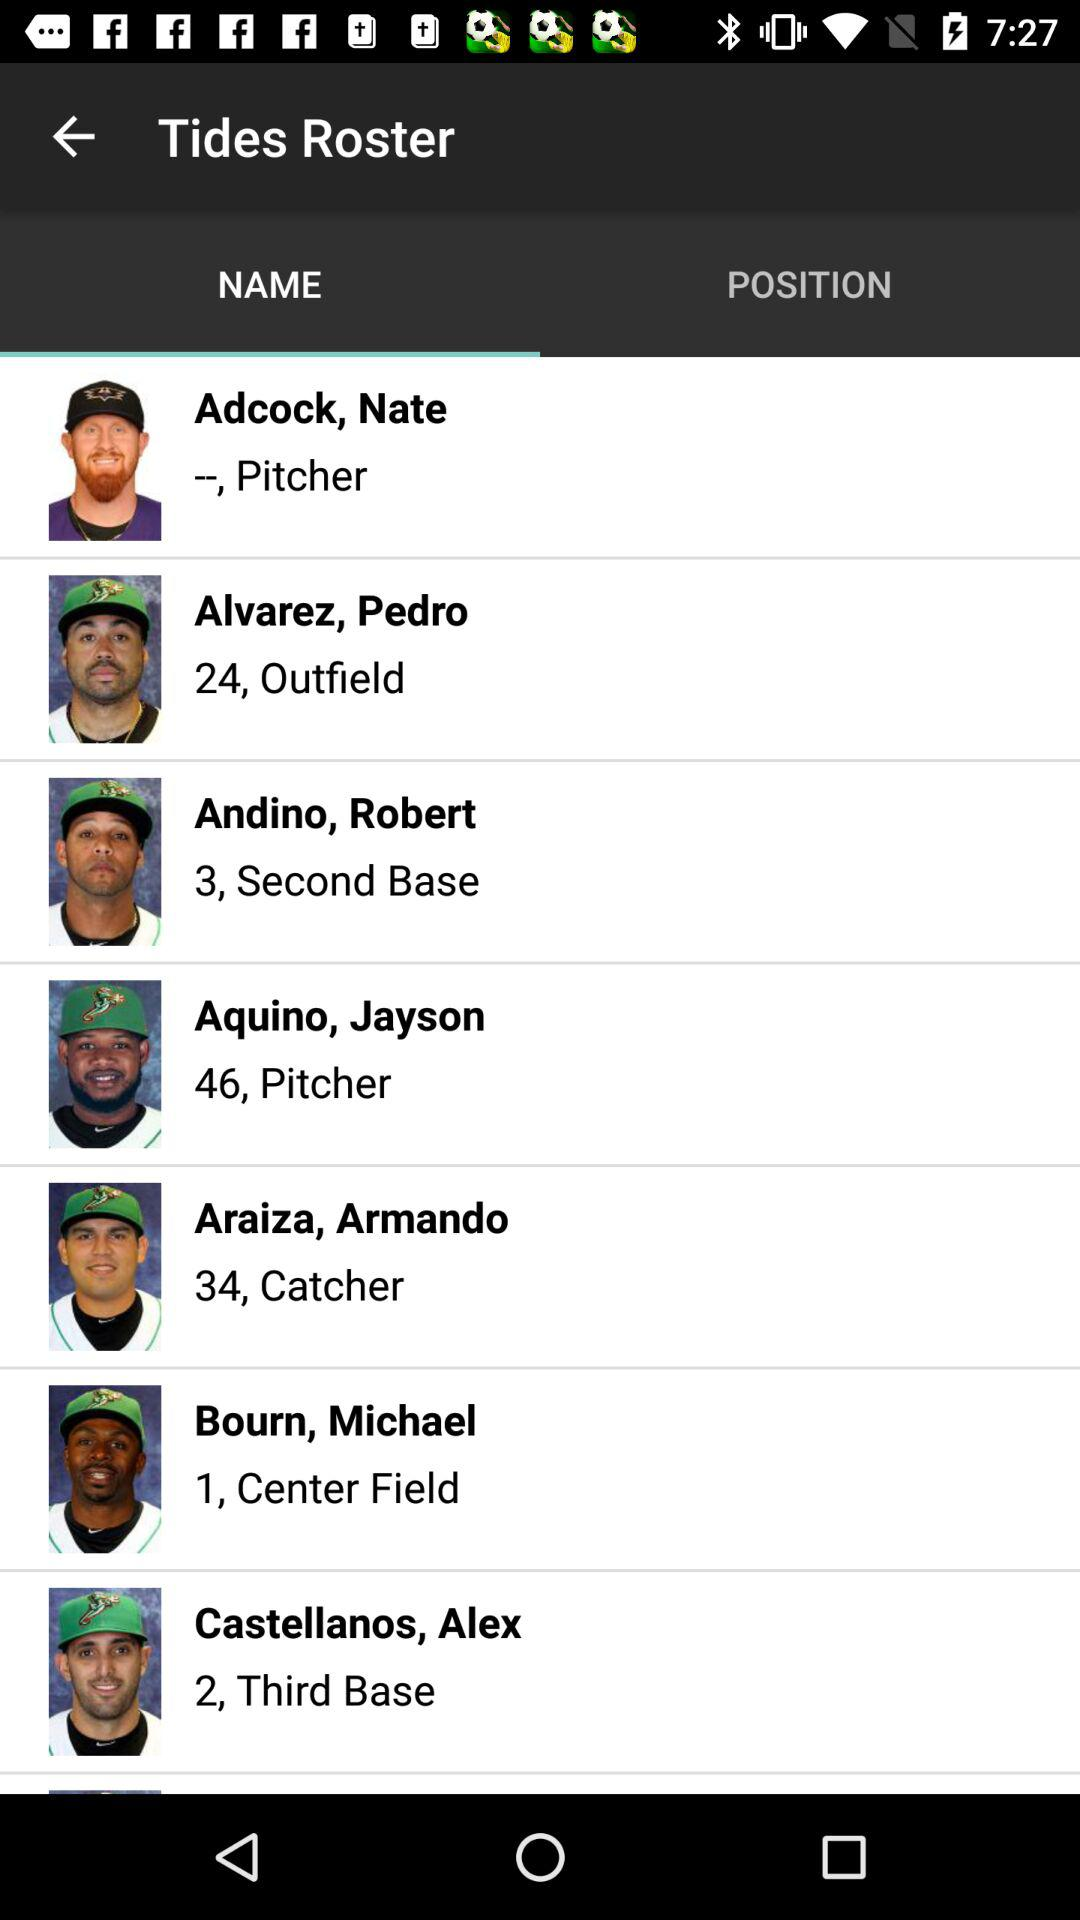Which option has been selected? The selected option is "NAME". 